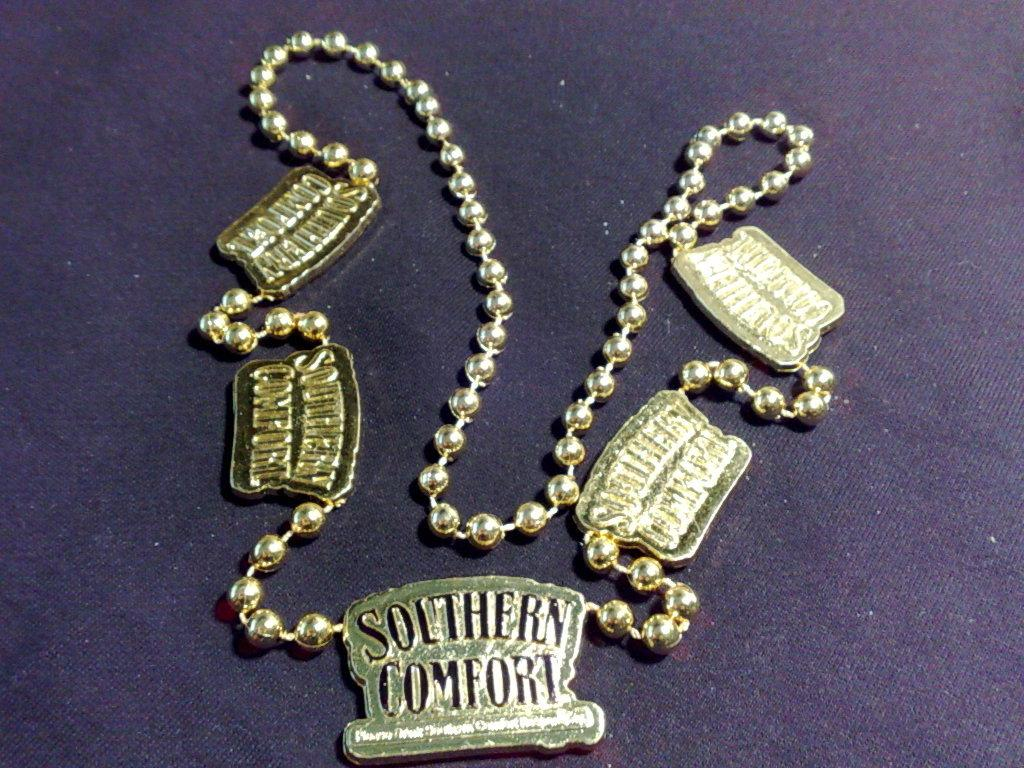<image>
Relay a brief, clear account of the picture shown. A necklace with a pediment that says Southern Comfort. 